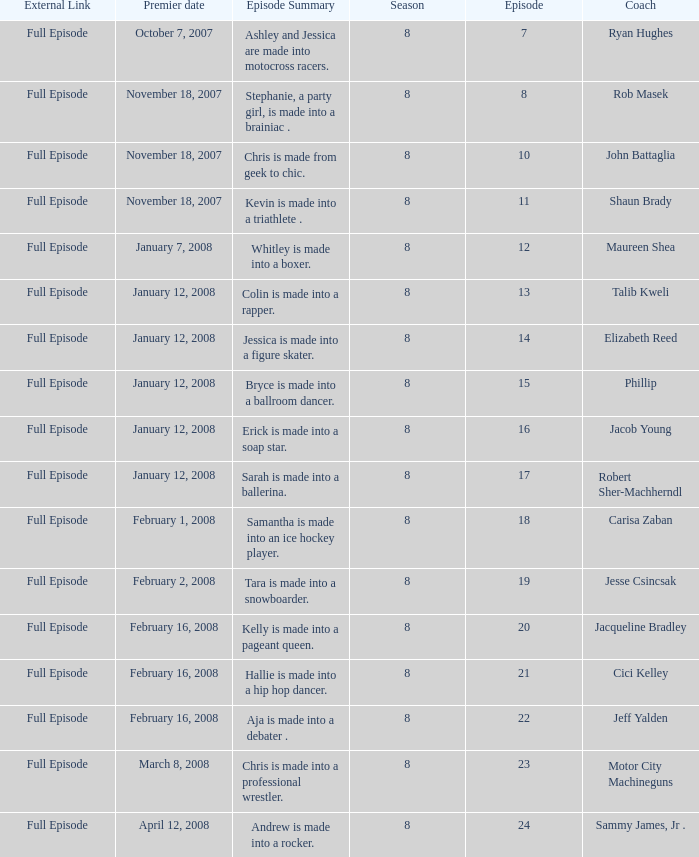Who was the coach for episode 15? Phillip. 